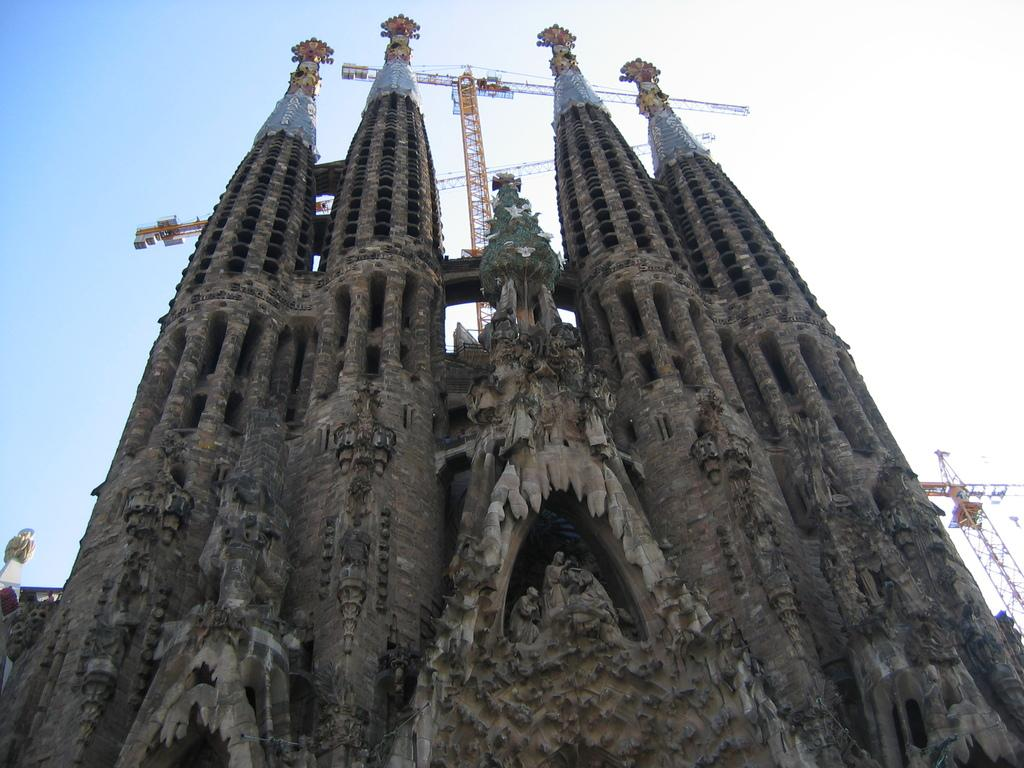What structures are visible in the image? There are towers in the image. What type of artwork can be seen in the image? There are sculptures of a person in the image. What material is used for the rods in the image? Metal rods are present in the image. What color is the sky in the background of the image? The sky is blue in the background of the image. When might this image have been taken? The image was likely taken during the day, as the sky is blue and there is sufficient light. What type of pie is being served on a square plate in the image? There is no pie or square plate present in the image. 